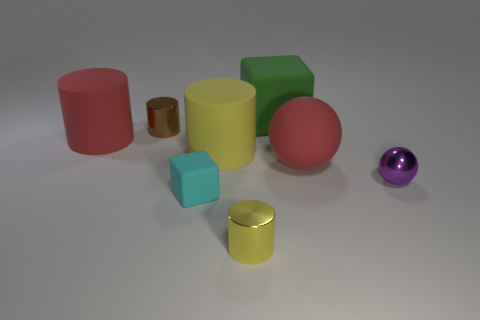Which objects look similar in size? The cube and the smaller cylinder seem to be quite similar in size. Does any object have a reflective surface? Yes, the small gold-colored cylinder has a shiny, reflective surface. 